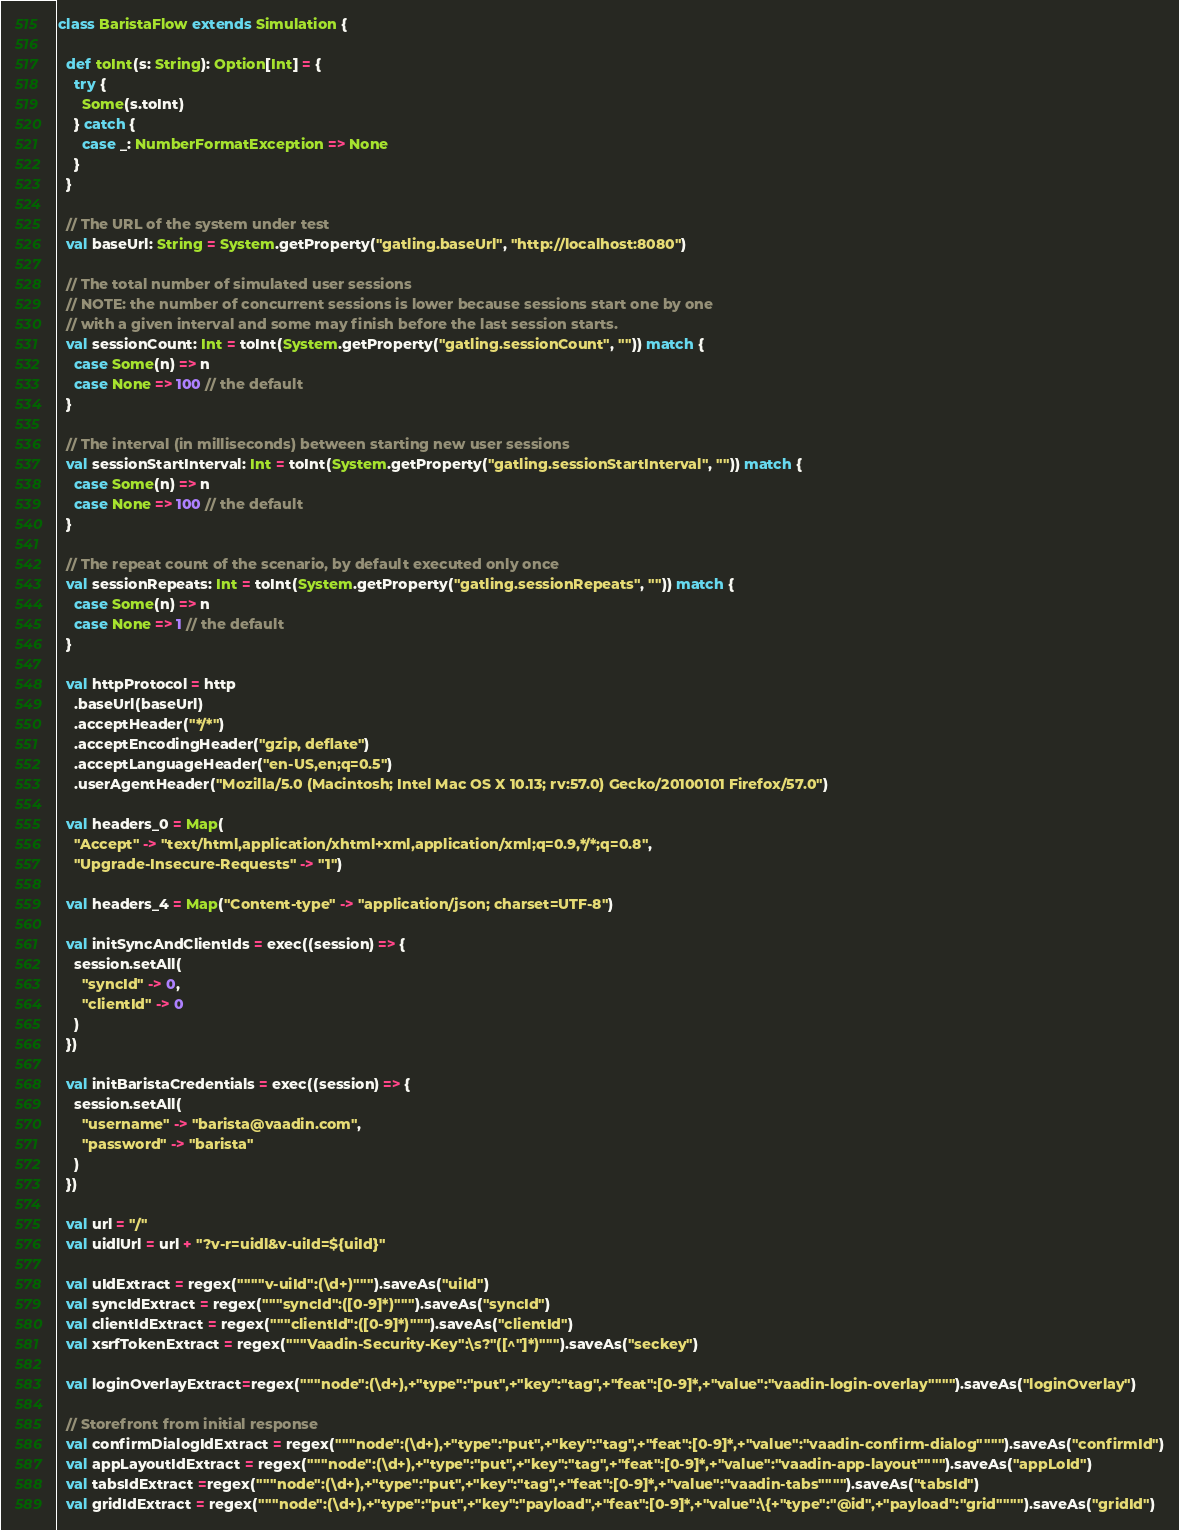<code> <loc_0><loc_0><loc_500><loc_500><_Scala_>

class BaristaFlow extends Simulation {

  def toInt(s: String): Option[Int] = {
    try {
      Some(s.toInt)
    } catch {
      case _: NumberFormatException => None
    }
  }

  // The URL of the system under test
  val baseUrl: String = System.getProperty("gatling.baseUrl", "http://localhost:8080")

  // The total number of simulated user sessions
  // NOTE: the number of concurrent sessions is lower because sessions start one by one
  // with a given interval and some may finish before the last session starts.
  val sessionCount: Int = toInt(System.getProperty("gatling.sessionCount", "")) match {
    case Some(n) => n
    case None => 100 // the default
  }

  // The interval (in milliseconds) between starting new user sessions
  val sessionStartInterval: Int = toInt(System.getProperty("gatling.sessionStartInterval", "")) match {
    case Some(n) => n
    case None => 100 // the default
  }

  // The repeat count of the scenario, by default executed only once
  val sessionRepeats: Int = toInt(System.getProperty("gatling.sessionRepeats", "")) match {
    case Some(n) => n
    case None => 1 // the default
  }

  val httpProtocol = http
    .baseUrl(baseUrl)
    .acceptHeader("*/*")
    .acceptEncodingHeader("gzip, deflate")
    .acceptLanguageHeader("en-US,en;q=0.5")
    .userAgentHeader("Mozilla/5.0 (Macintosh; Intel Mac OS X 10.13; rv:57.0) Gecko/20100101 Firefox/57.0")

  val headers_0 = Map(
    "Accept" -> "text/html,application/xhtml+xml,application/xml;q=0.9,*/*;q=0.8",
    "Upgrade-Insecure-Requests" -> "1")

  val headers_4 = Map("Content-type" -> "application/json; charset=UTF-8")

  val initSyncAndClientIds = exec((session) => {
    session.setAll(
      "syncId" -> 0,
      "clientId" -> 0
    )
  })

  val initBaristaCredentials = exec((session) => {
    session.setAll(
      "username" -> "barista@vaadin.com",
      "password" -> "barista"
    )
  })

  val url = "/"
  val uidlUrl = url + "?v-r=uidl&v-uiId=${uiId}"

  val uIdExtract = regex(""""v-uiId":(\d+)""").saveAs("uiId")
  val syncIdExtract = regex("""syncId":([0-9]*)""").saveAs("syncId")
  val clientIdExtract = regex("""clientId":([0-9]*)""").saveAs("clientId")
  val xsrfTokenExtract = regex("""Vaadin-Security-Key":\s?"([^"]*)""").saveAs("seckey")

  val loginOverlayExtract=regex("""node":(\d+),+"type":"put",+"key":"tag",+"feat":[0-9]*,+"value":"vaadin-login-overlay"""").saveAs("loginOverlay")

  // Storefront from initial response
  val confirmDialogIdExtract = regex("""node":(\d+),+"type":"put",+"key":"tag",+"feat":[0-9]*,+"value":"vaadin-confirm-dialog"""").saveAs("confirmId")
  val appLayoutIdExtract = regex("""node":(\d+),+"type":"put",+"key":"tag",+"feat":[0-9]*,+"value":"vaadin-app-layout"""").saveAs("appLoId")
  val tabsIdExtract =regex("""node":(\d+),+"type":"put",+"key":"tag",+"feat":[0-9]*,+"value":"vaadin-tabs"""").saveAs("tabsId")
  val gridIdExtract = regex("""node":(\d+),+"type":"put",+"key":"payload",+"feat":[0-9]*,+"value":\{+"type":"@id",+"payload":"grid"""").saveAs("gridId")</code> 